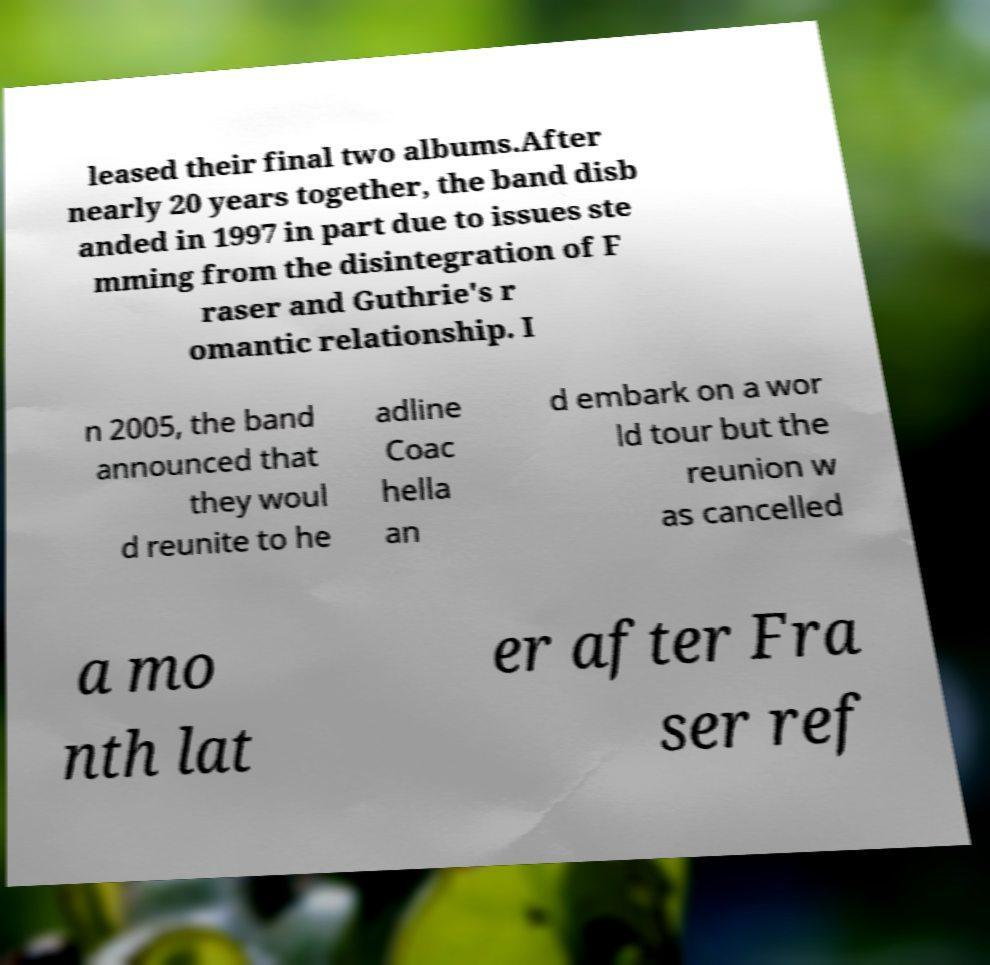There's text embedded in this image that I need extracted. Can you transcribe it verbatim? leased their final two albums.After nearly 20 years together, the band disb anded in 1997 in part due to issues ste mming from the disintegration of F raser and Guthrie's r omantic relationship. I n 2005, the band announced that they woul d reunite to he adline Coac hella an d embark on a wor ld tour but the reunion w as cancelled a mo nth lat er after Fra ser ref 